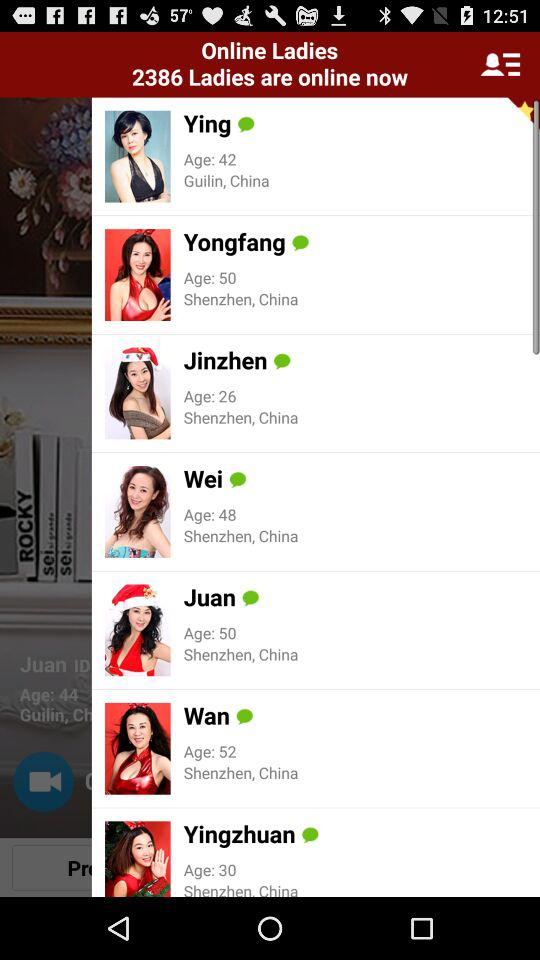How old is Wei? Wei is 48 years old. 